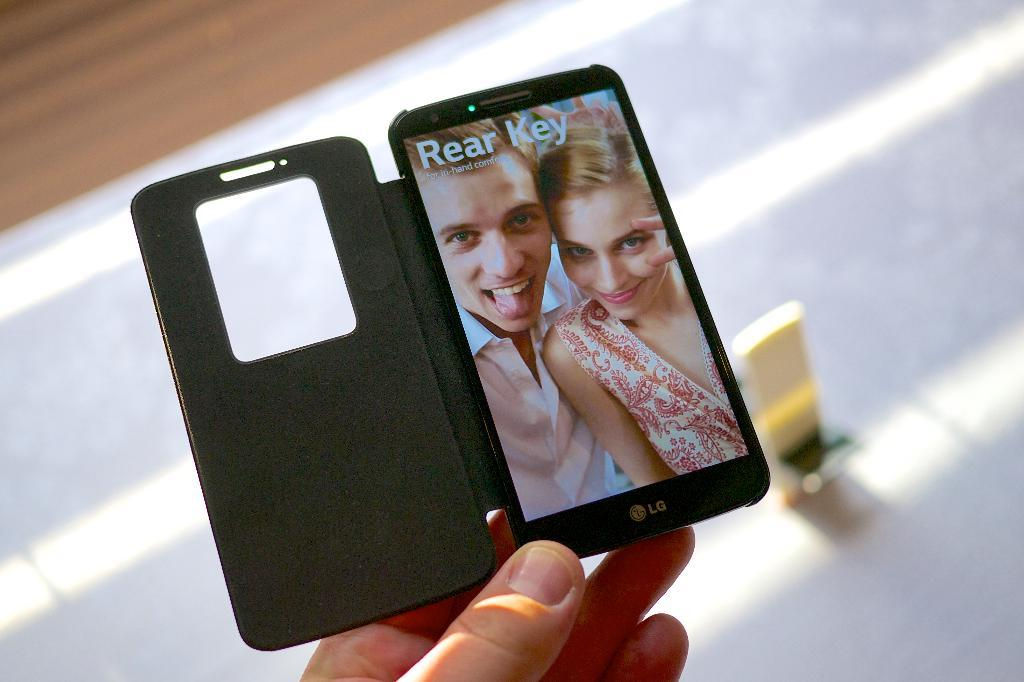<image>
Write a terse but informative summary of the picture. Person holding a phone that says Rear key on it. 